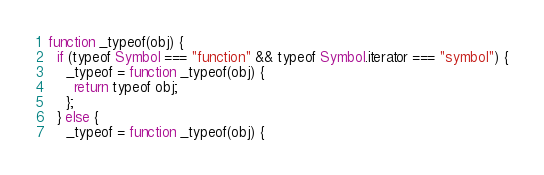Convert code to text. <code><loc_0><loc_0><loc_500><loc_500><_JavaScript_>function _typeof(obj) {
  if (typeof Symbol === "function" && typeof Symbol.iterator === "symbol") {
    _typeof = function _typeof(obj) {
      return typeof obj;
    };
  } else {
    _typeof = function _typeof(obj) {</code> 